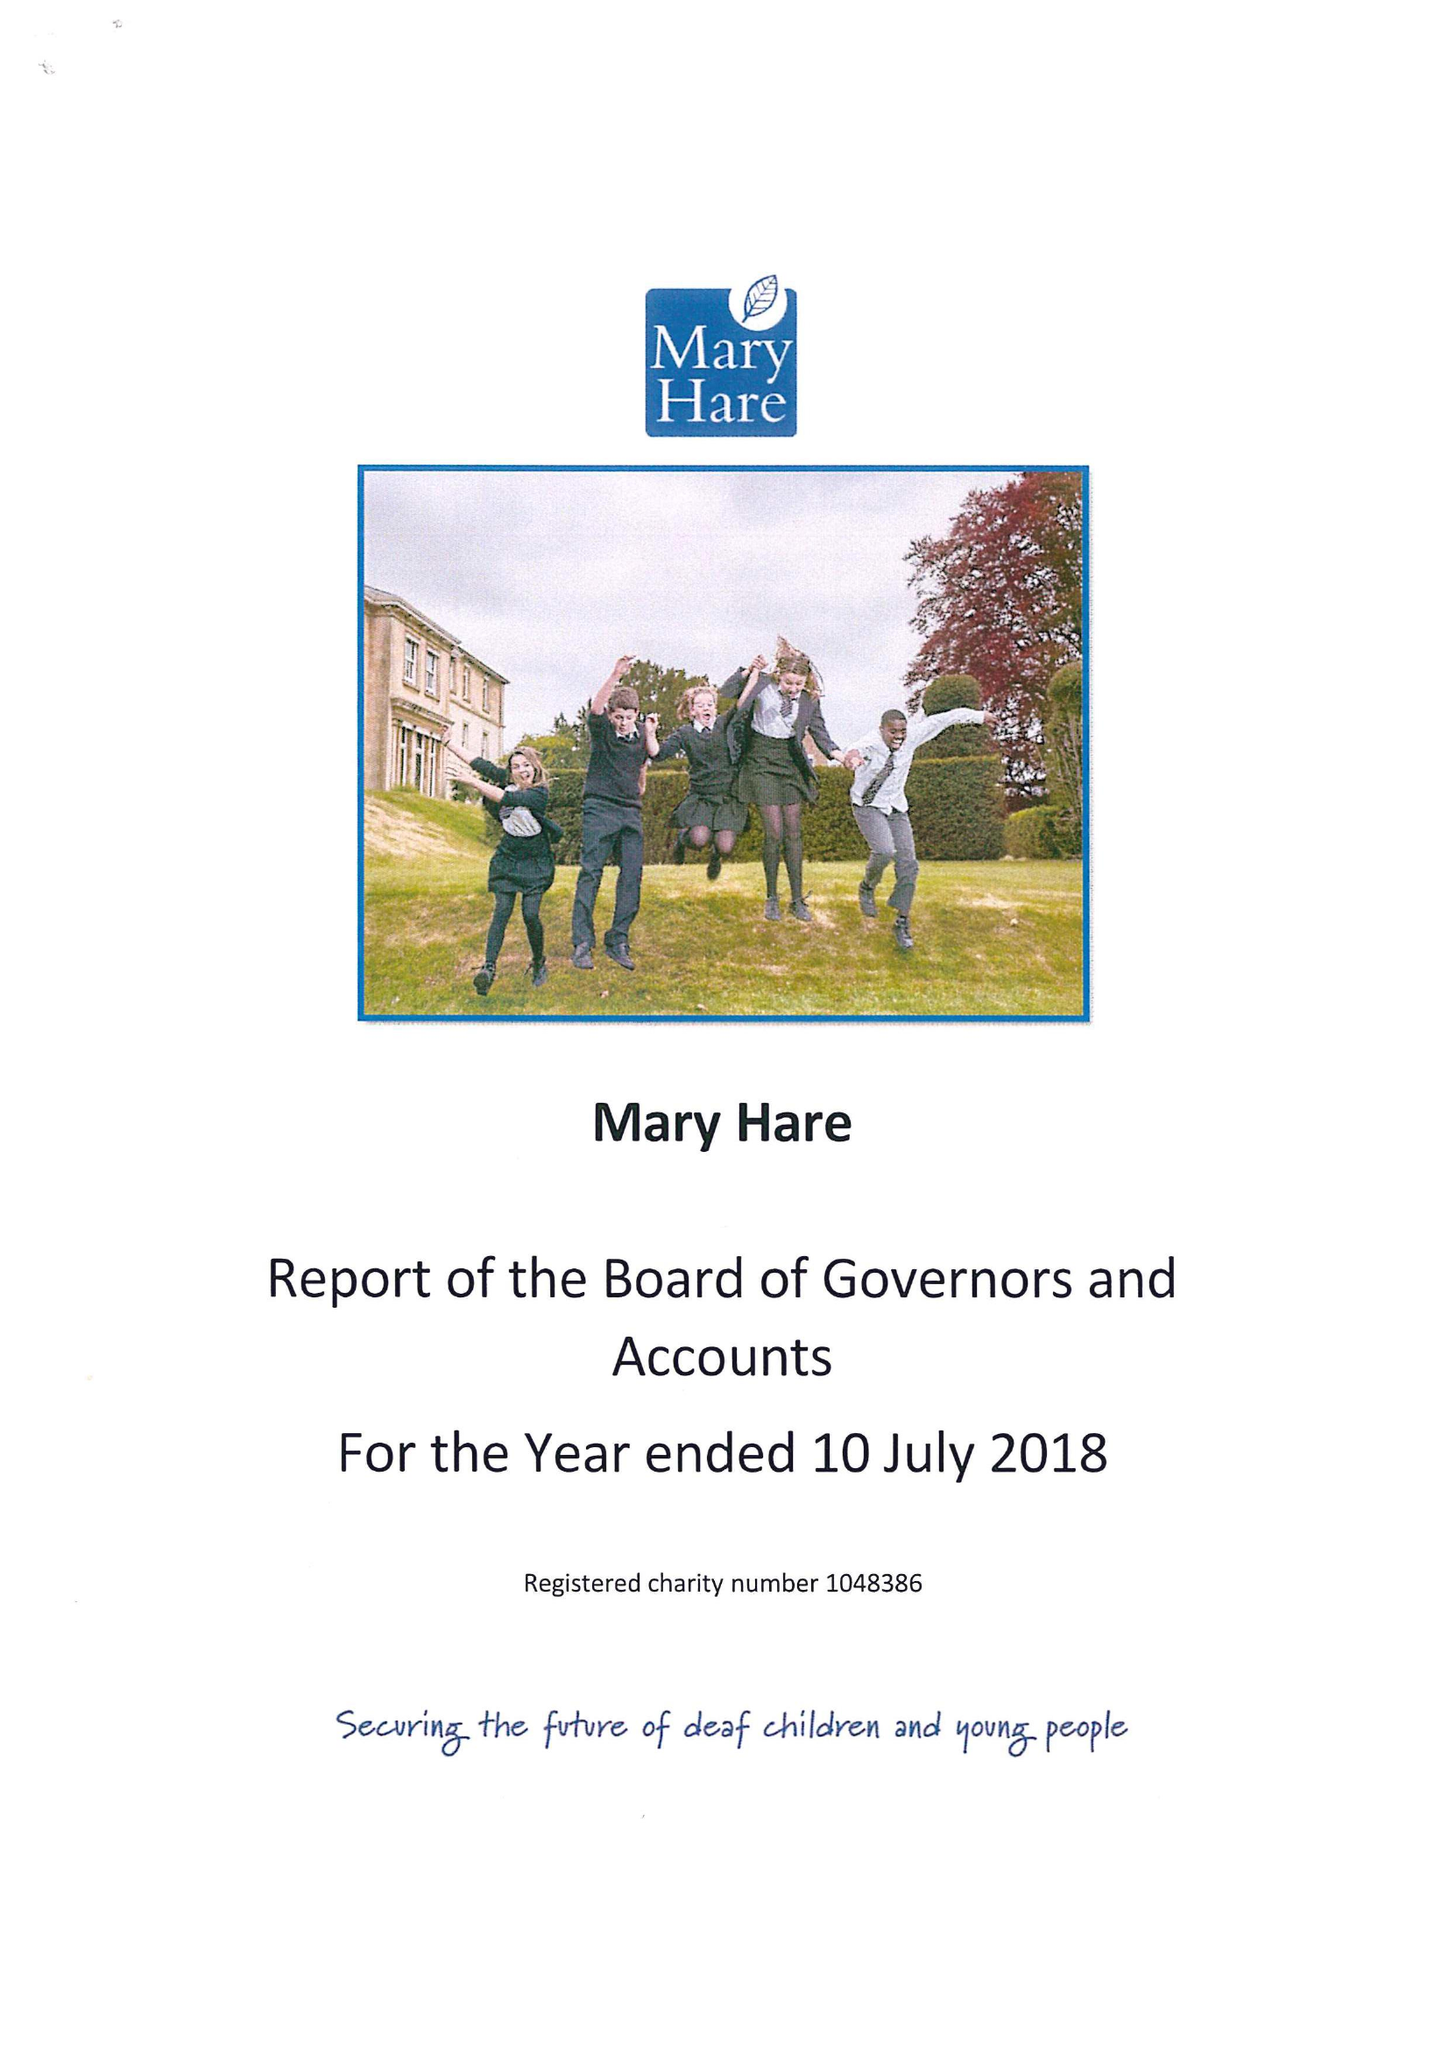What is the value for the address__street_line?
Answer the question using a single word or phrase. NEWBURY 